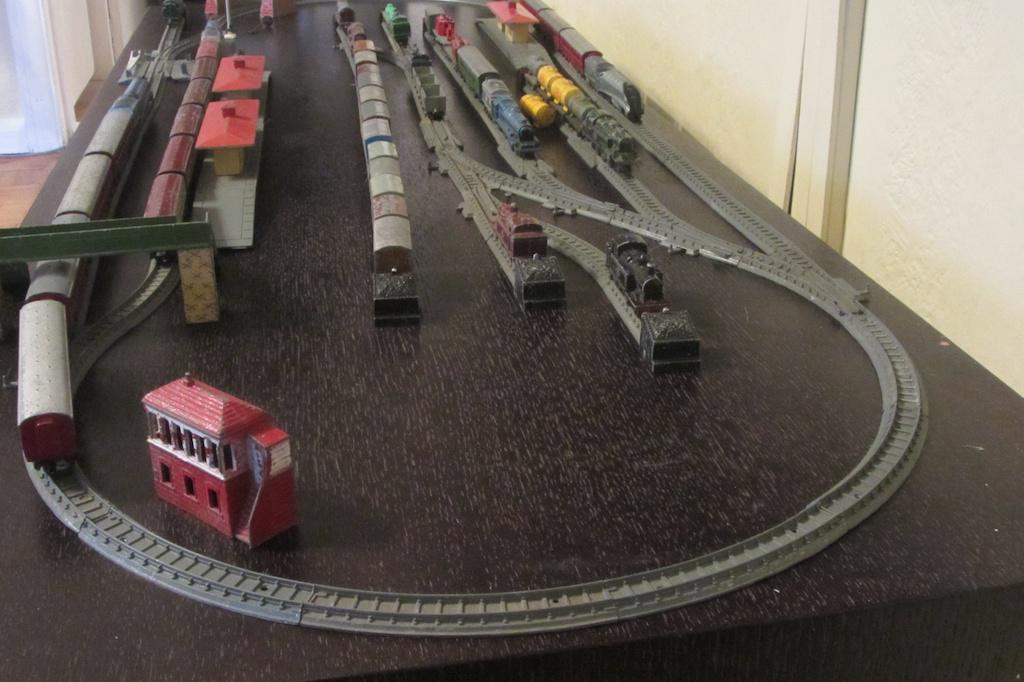What type of toys are present in the image? There are toy trains in the image. What are the toy trains placed on? There are toy railway tracks in the image. What can be seen in the background of the image? Walls are visible in the background of the image. What type of eggnog is being served in the image? There is no eggnog present in the image; it features toy trains and railway tracks. What is the zinc content of the toy trains in the image? The zinc content of the toy trains cannot be determined from the image, as it does not provide information about the materials used in their construction. 